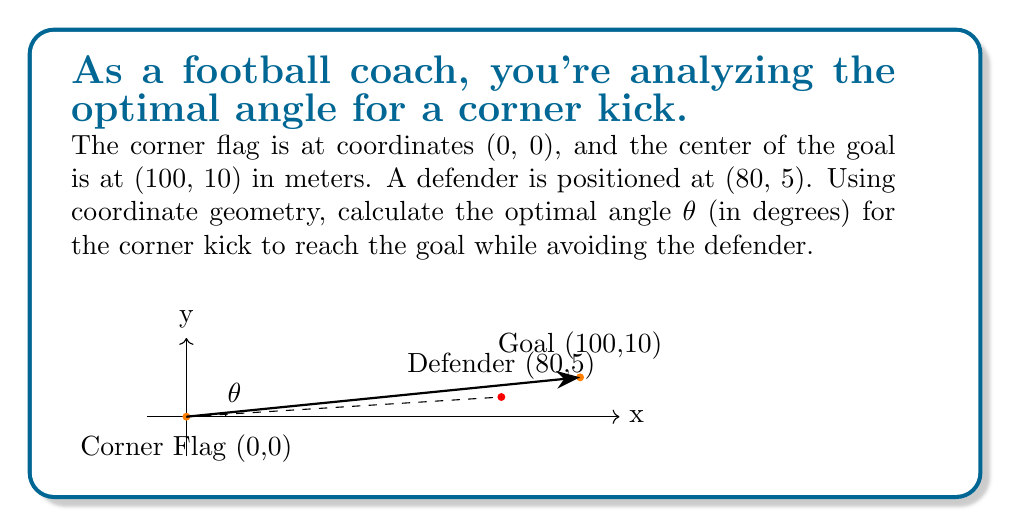Teach me how to tackle this problem. Let's approach this step-by-step:

1) First, we need to find the angle between the x-axis and the line from the corner flag to the goal. We can do this using the arctangent function:

   $$\theta_{goal} = \arctan(\frac{10}{100}) = \arctan(0.1)$$

2) Similarly, we can find the angle to the defender:

   $$\theta_{defender} = \arctan(\frac{5}{80}) = \arctan(0.0625)$$

3) The optimal angle should be slightly larger than the angle to the defender to ensure the ball passes over the defender. Let's add a small buffer of 1°:

   $$\theta_{optimal} = \theta_{defender} + 1°$$

4) Calculate the angles:
   
   $$\theta_{goal} = \arctan(0.1) \approx 5.71°$$
   $$\theta_{defender} = \arctan(0.0625) \approx 3.58°$$
   $$\theta_{optimal} = 3.58° + 1° = 4.58°$$

5) Convert to degrees:
   
   $$\theta_{optimal} = 4.58°$$

This angle is less than the angle to the goal, ensuring the ball can reach the goal while avoiding the defender.
Answer: 4.58° 